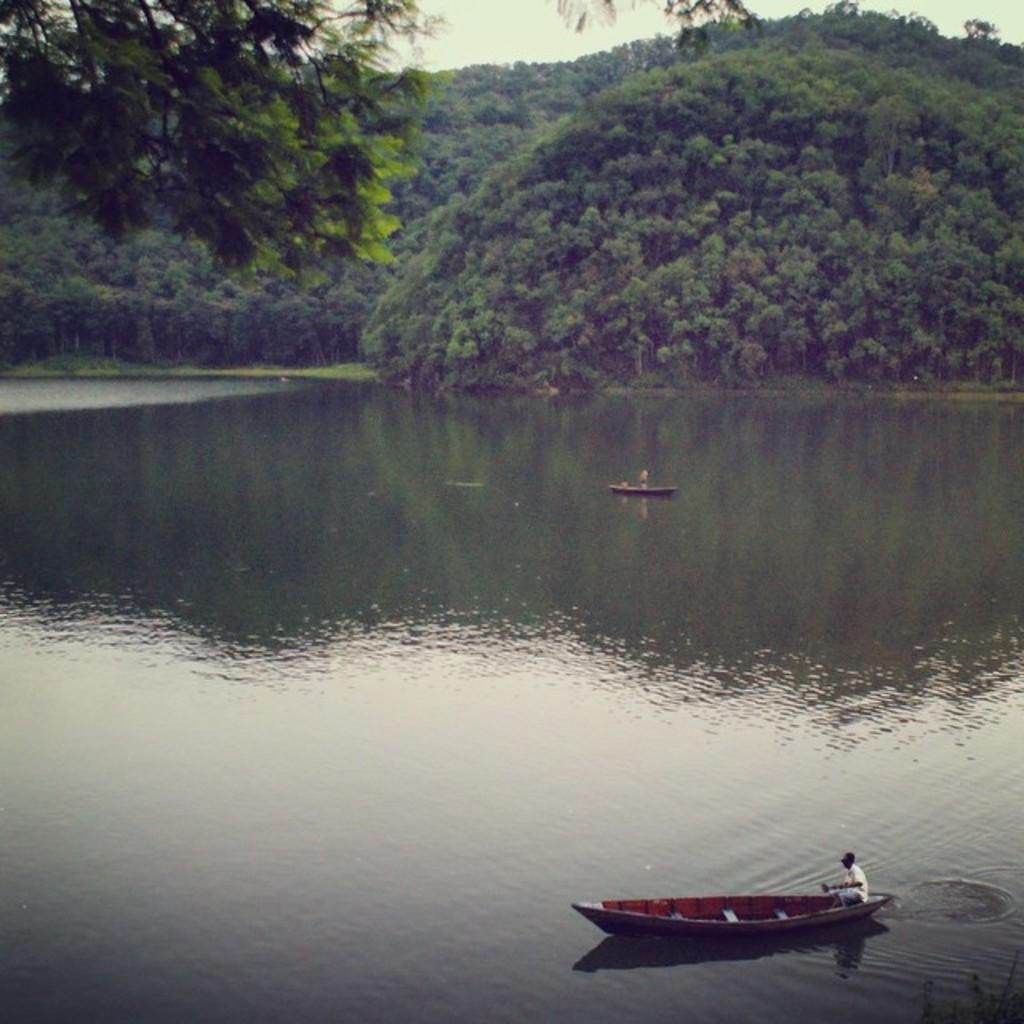What body of water is present in the image? There is a river in the image. What is floating on the water in the image? There are two boats floating on the water in the image. What can be seen in the background of the image? There are trees and the sky visible in the background of the image. Where is the cart located in the image? There is no cart present in the image. Can you see any caves in the background of the image? There are no caves visible in the image; only trees and the sky are present in the background. 